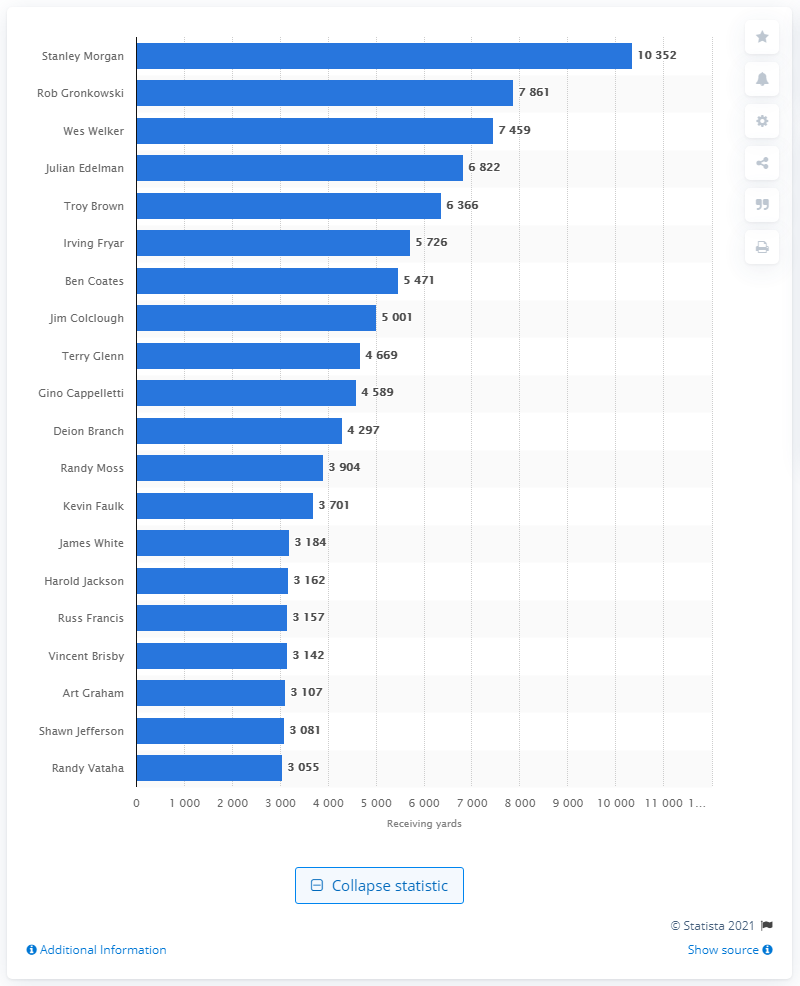Indicate a few pertinent items in this graphic. Stanley Morgan is the career receiving leader of the New England Patriots. 